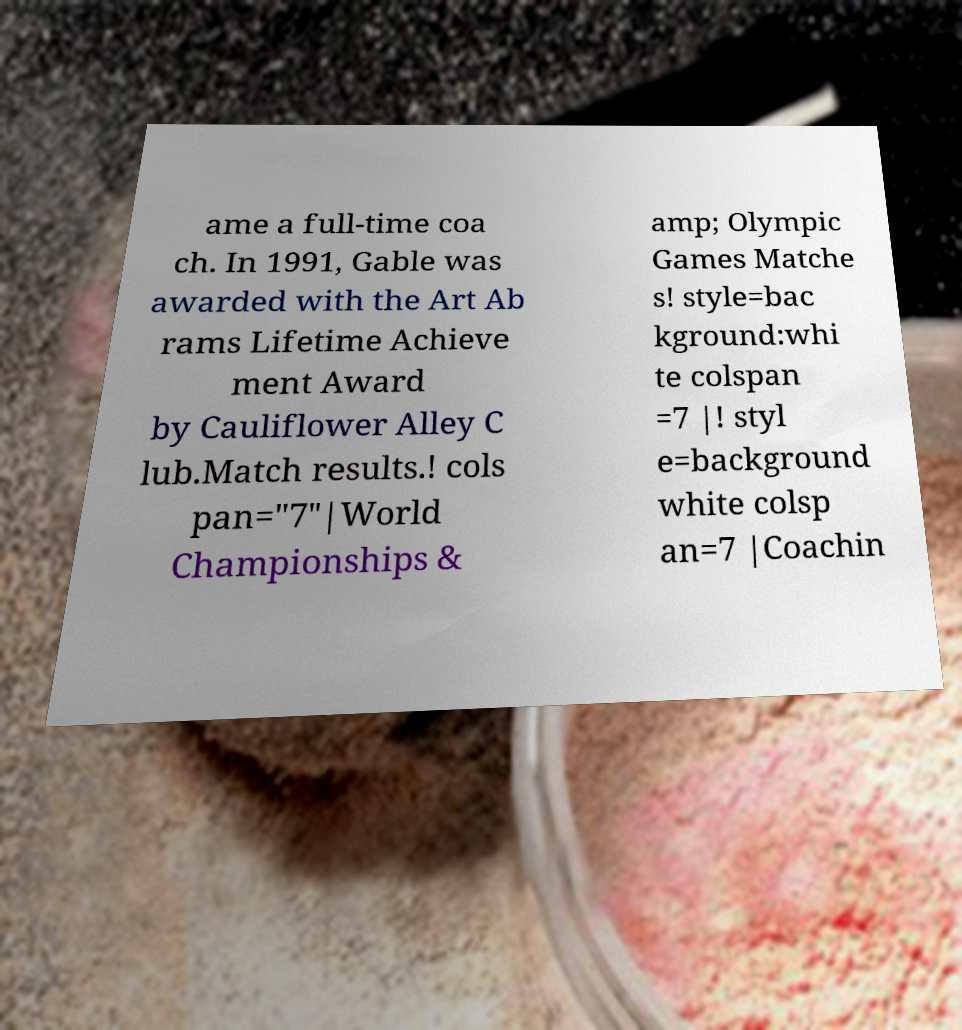I need the written content from this picture converted into text. Can you do that? ame a full-time coa ch. In 1991, Gable was awarded with the Art Ab rams Lifetime Achieve ment Award by Cauliflower Alley C lub.Match results.! cols pan="7"|World Championships & amp; Olympic Games Matche s! style=bac kground:whi te colspan =7 |! styl e=background white colsp an=7 |Coachin 